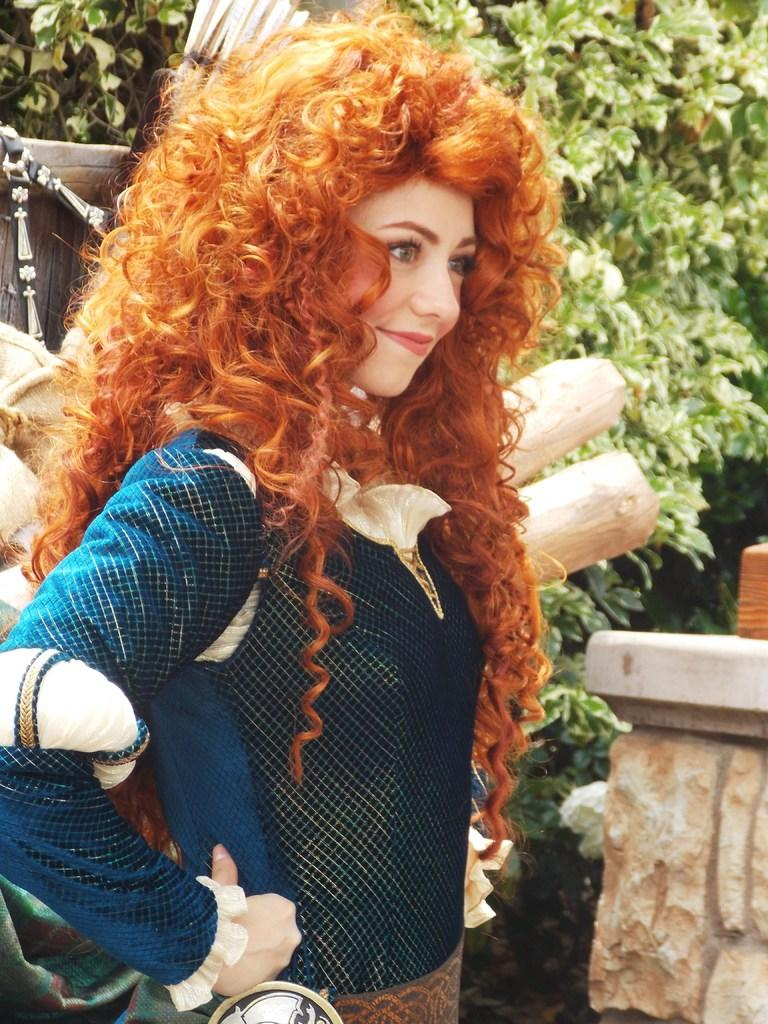What is the woman doing in the image? The woman is standing in the image. What is the woman's facial expression in the image? The woman is smiling in the image. What objects can be seen in the image besides the woman? There are wooden sticks and a plant with leaves in the image. How are the wooden sticks being used for distribution in the image? There is no indication in the image that the wooden sticks are being used for distribution. 